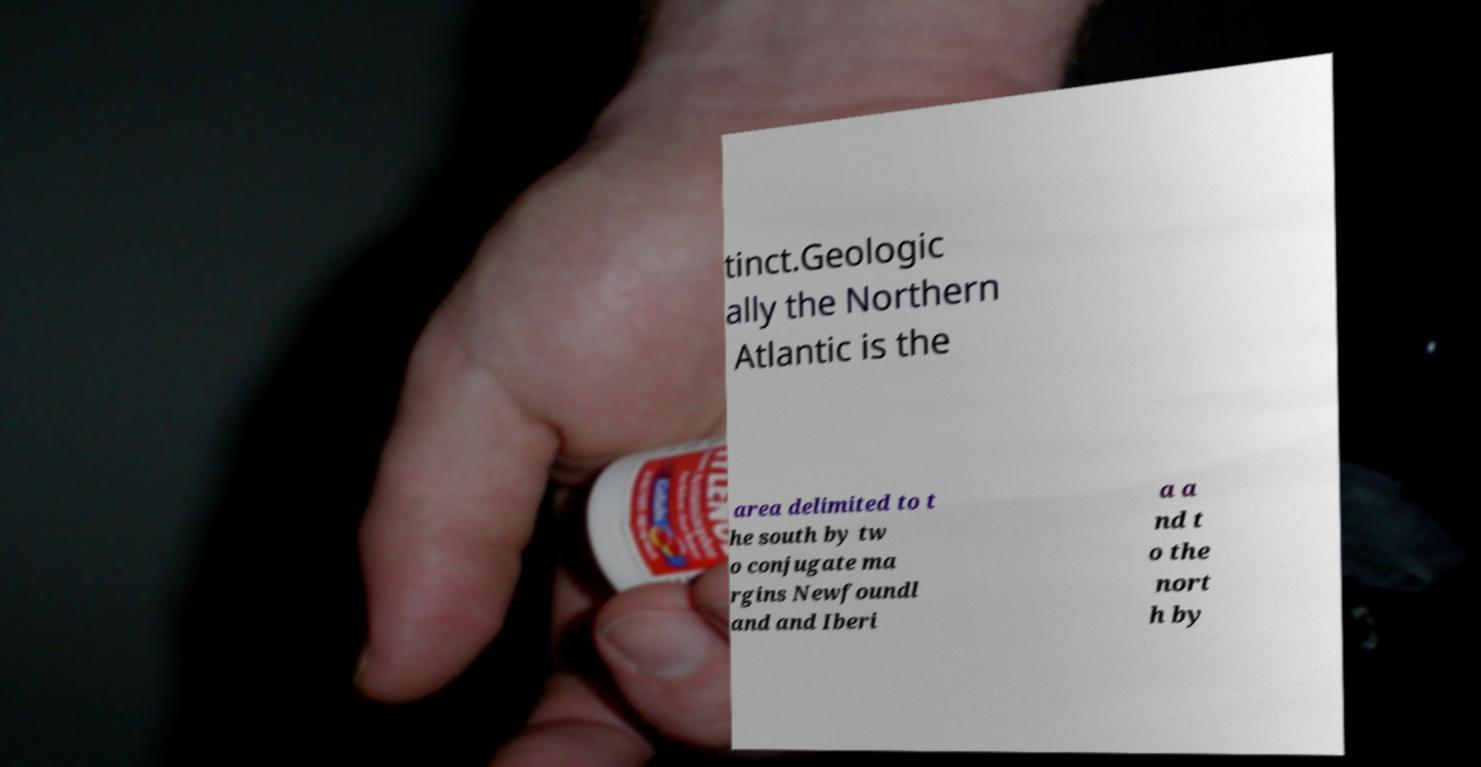Can you accurately transcribe the text from the provided image for me? tinct.Geologic ally the Northern Atlantic is the area delimited to t he south by tw o conjugate ma rgins Newfoundl and and Iberi a a nd t o the nort h by 